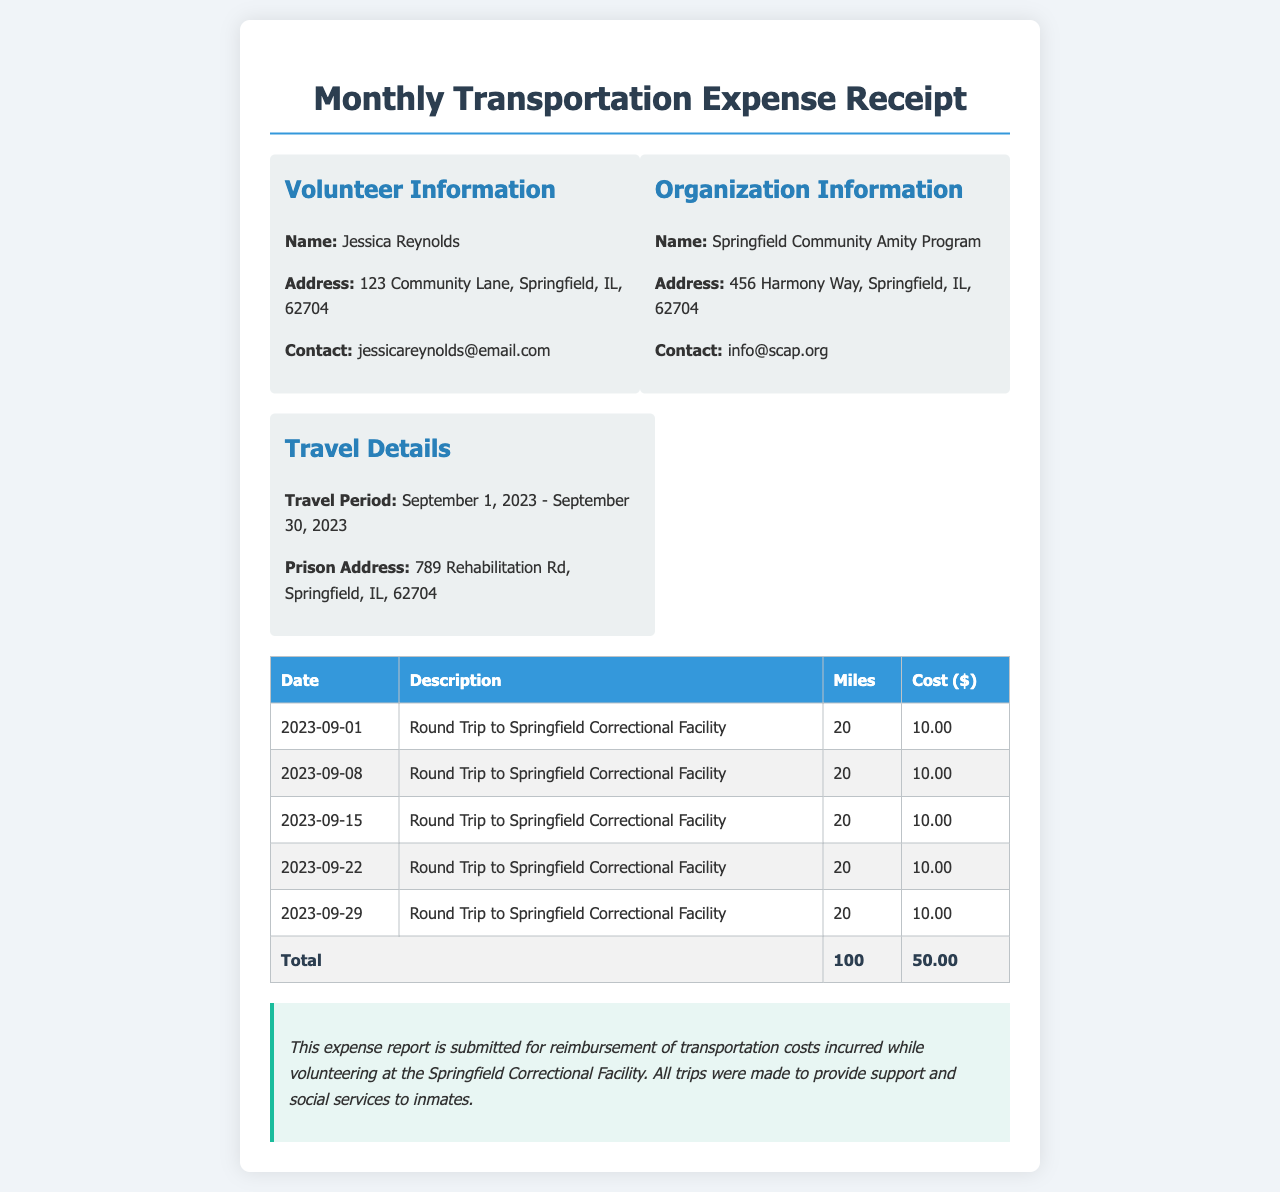What is the name of the volunteer? The volunteer's name is mentioned in the "Volunteer Information" section of the document.
Answer: Jessica Reynolds What is the total amount for reimbursement? The total amount is calculated from the individual costs listed in the expense table.
Answer: 50.00 What is the travel period mentioned in the receipt? The travel period is indicated in the "Travel Details" section of the document.
Answer: September 1, 2023 - September 30, 2023 How many miles were traveled in total? The total miles traveled can be calculated from the individual trips listed in the expense table.
Answer: 100 What is the address of the organization? The organization’s address is specified in the "Organization Information" section.
Answer: 456 Harmony Way, Springfield, IL, 62704 What type of trips were made according to the receipt? The nature of the trips is described in the "Description" column of the table.
Answer: Round Trip to Springfield Correctional Facility Which prison is mentioned in the travel details? The specific prison is stated in the "Travel Details" section of the document.
Answer: Springfield Correctional Facility How many trips were made in total? The total number of trips can be calculated from the rows of the expense table.
Answer: 5 